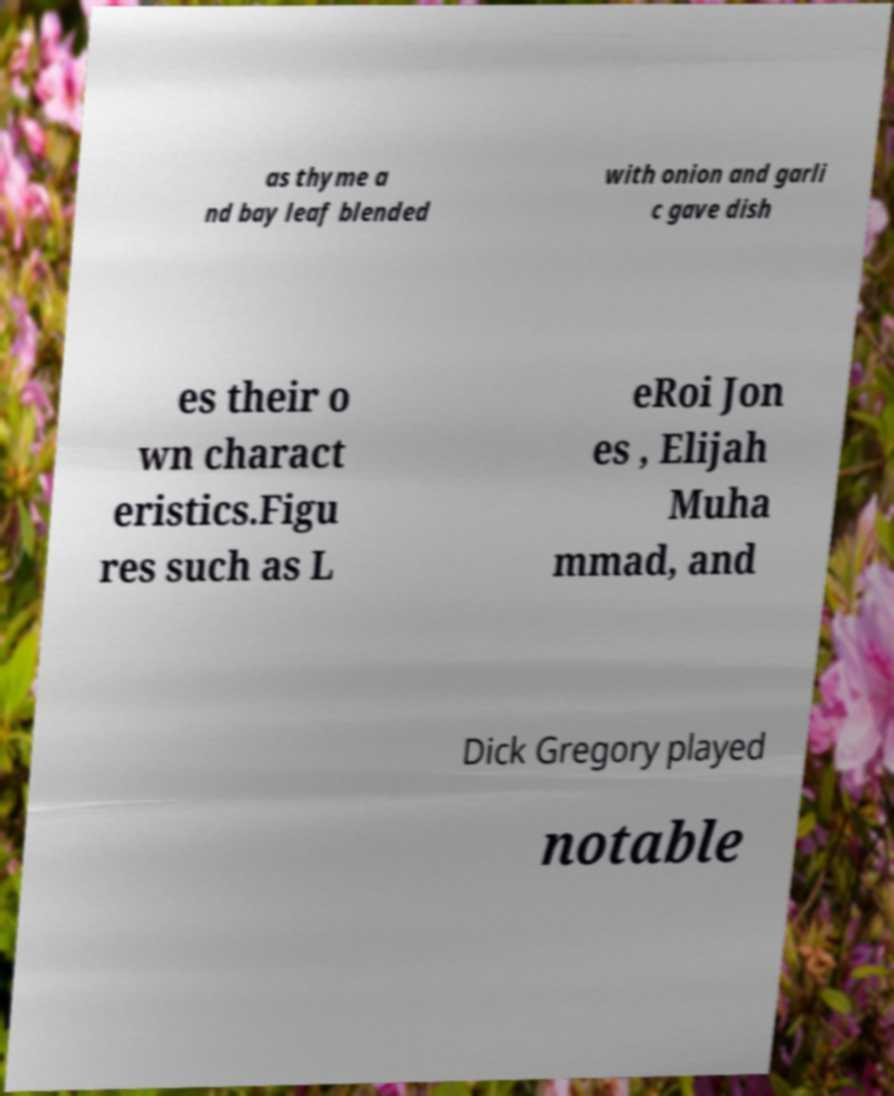What messages or text are displayed in this image? I need them in a readable, typed format. as thyme a nd bay leaf blended with onion and garli c gave dish es their o wn charact eristics.Figu res such as L eRoi Jon es , Elijah Muha mmad, and Dick Gregory played notable 